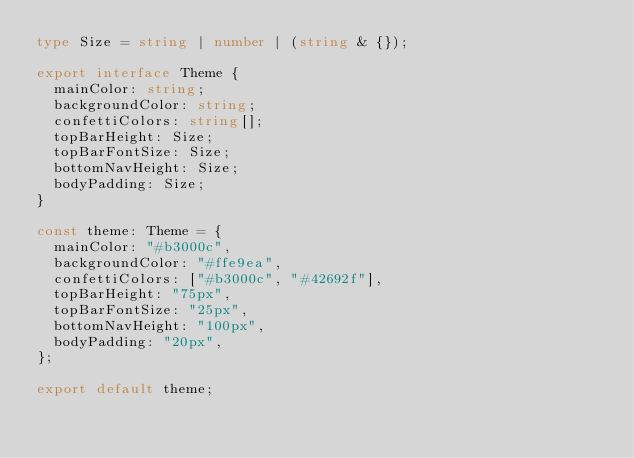Convert code to text. <code><loc_0><loc_0><loc_500><loc_500><_TypeScript_>type Size = string | number | (string & {});

export interface Theme {
  mainColor: string;
  backgroundColor: string;
  confettiColors: string[];
  topBarHeight: Size;
  topBarFontSize: Size;
  bottomNavHeight: Size;
  bodyPadding: Size;
}

const theme: Theme = {
  mainColor: "#b3000c",
  backgroundColor: "#ffe9ea",
  confettiColors: ["#b3000c", "#42692f"],
  topBarHeight: "75px",
  topBarFontSize: "25px",
  bottomNavHeight: "100px",
  bodyPadding: "20px",
};

export default theme;
</code> 